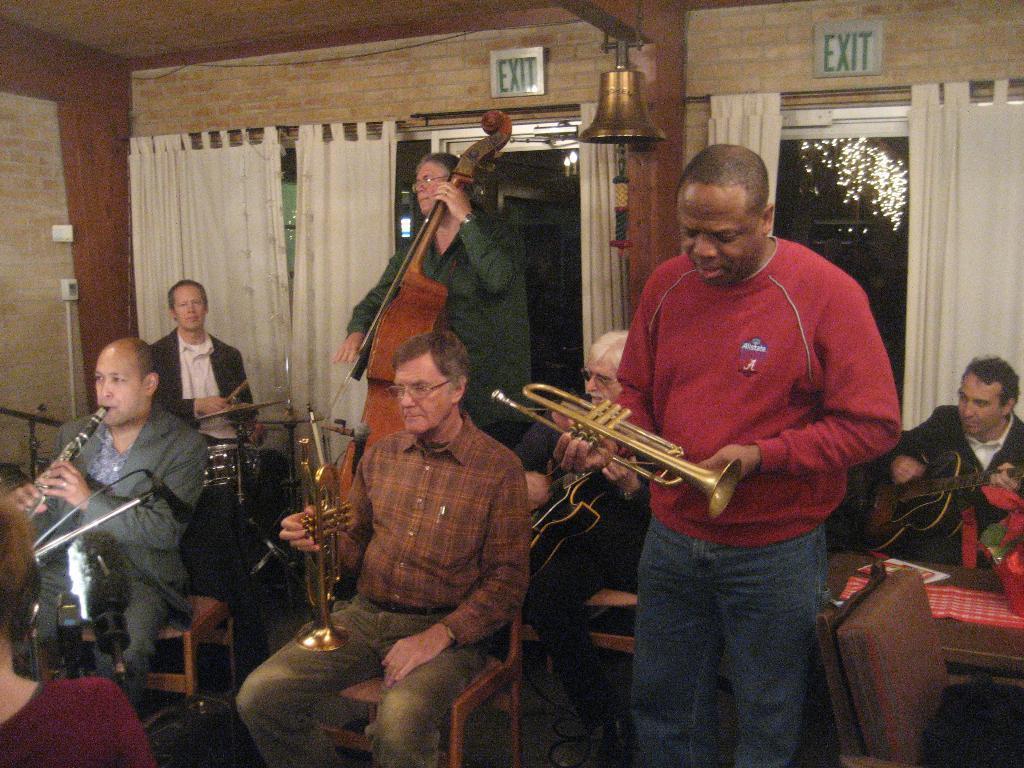Please provide a concise description of this image. In this image I can see few persons are sitting on chairs and few persons standing are holding musical instruments in their hands. I can see the wall, few curtains, the ceiling, two exit boards, a bell and few lights. 